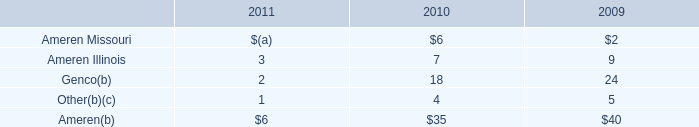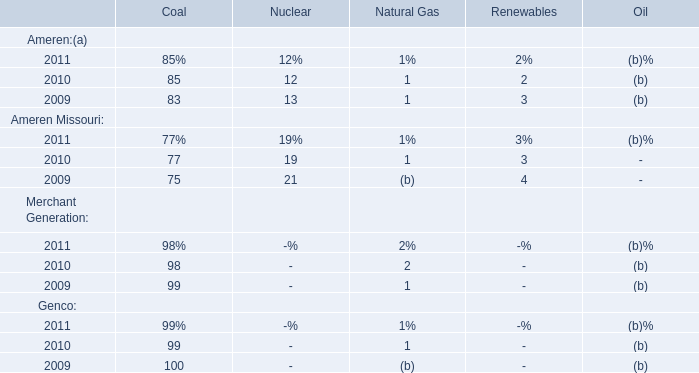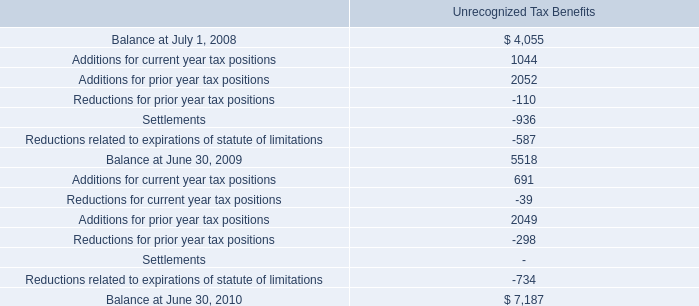if the companies accounting policy were to include accrued interest and penalties in utp , what would the balance be as of at june 30 2010? 
Computations: (7187 + 890)
Answer: 8077.0. 